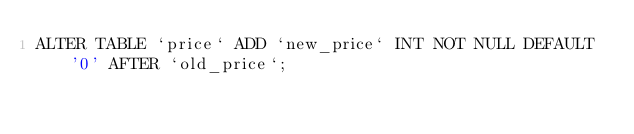Convert code to text. <code><loc_0><loc_0><loc_500><loc_500><_SQL_>ALTER TABLE `price` ADD `new_price` INT NOT NULL DEFAULT '0' AFTER `old_price`; </code> 